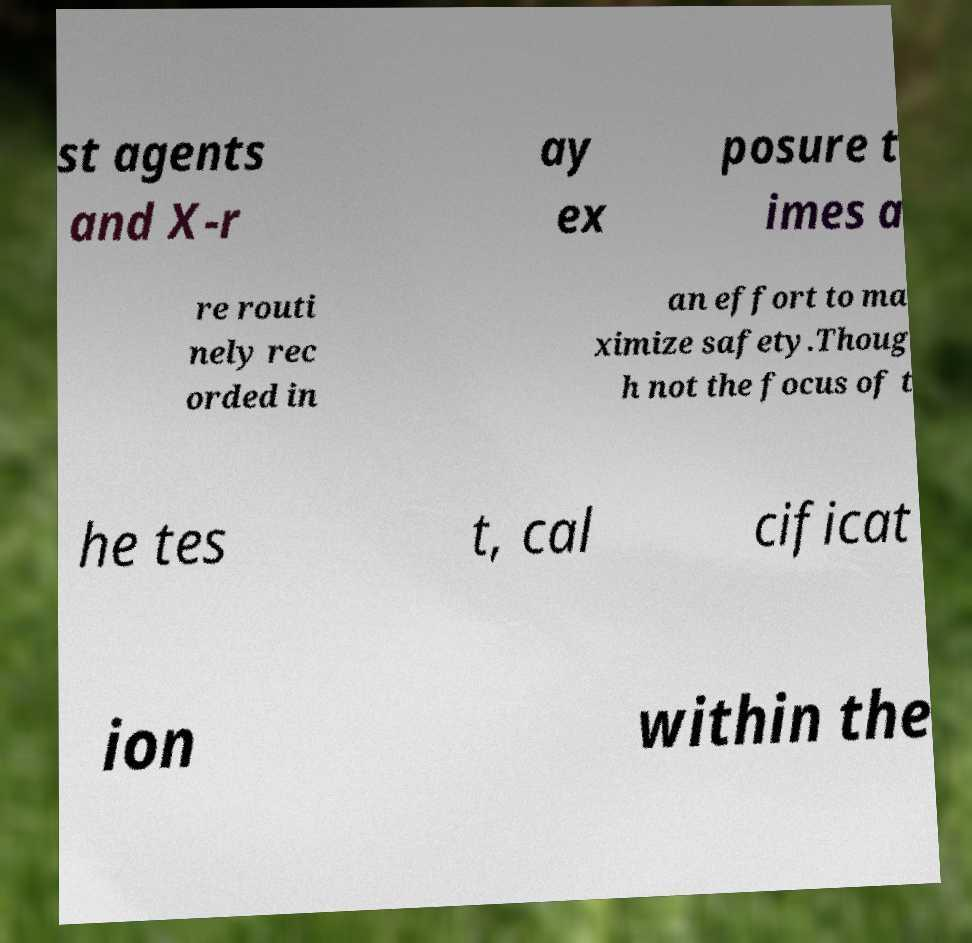Can you read and provide the text displayed in the image?This photo seems to have some interesting text. Can you extract and type it out for me? st agents and X-r ay ex posure t imes a re routi nely rec orded in an effort to ma ximize safety.Thoug h not the focus of t he tes t, cal cificat ion within the 